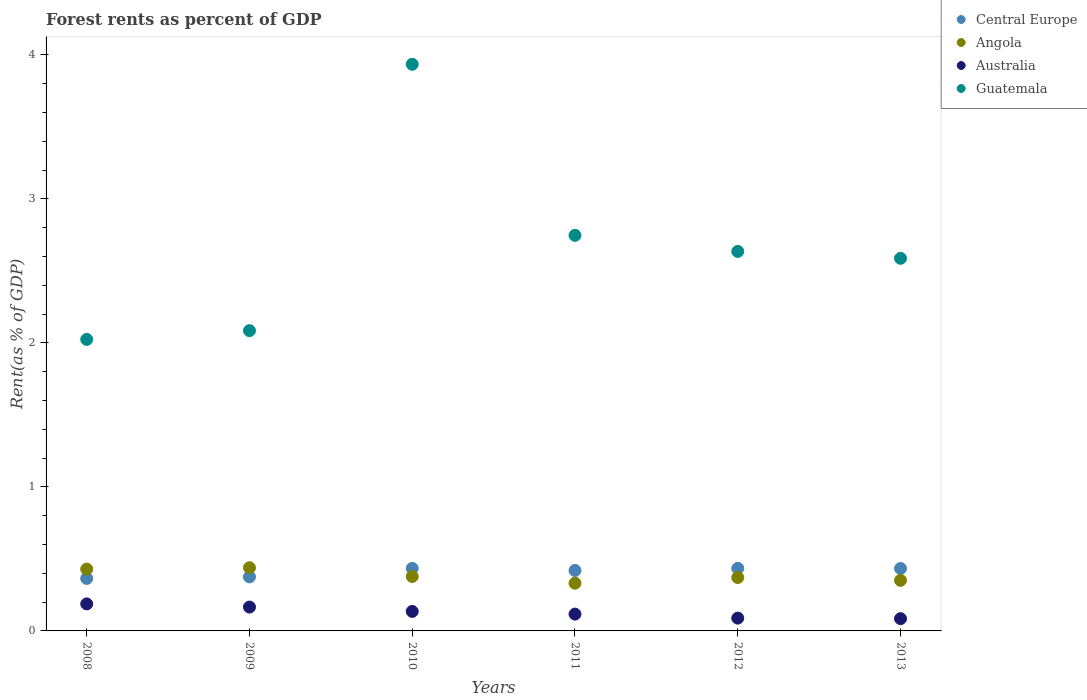What is the forest rent in Central Europe in 2013?
Offer a very short reply. 0.43. Across all years, what is the maximum forest rent in Central Europe?
Offer a very short reply. 0.43. Across all years, what is the minimum forest rent in Angola?
Give a very brief answer. 0.33. In which year was the forest rent in Central Europe minimum?
Your answer should be compact. 2008. What is the total forest rent in Angola in the graph?
Your response must be concise. 2.3. What is the difference between the forest rent in Angola in 2009 and that in 2011?
Provide a short and direct response. 0.11. What is the difference between the forest rent in Guatemala in 2011 and the forest rent in Angola in 2009?
Provide a succinct answer. 2.31. What is the average forest rent in Australia per year?
Give a very brief answer. 0.13. In the year 2010, what is the difference between the forest rent in Guatemala and forest rent in Central Europe?
Your answer should be very brief. 3.5. In how many years, is the forest rent in Guatemala greater than 2 %?
Offer a very short reply. 6. What is the ratio of the forest rent in Angola in 2009 to that in 2013?
Your answer should be very brief. 1.25. What is the difference between the highest and the second highest forest rent in Guatemala?
Offer a very short reply. 1.19. What is the difference between the highest and the lowest forest rent in Central Europe?
Offer a terse response. 0.07. In how many years, is the forest rent in Central Europe greater than the average forest rent in Central Europe taken over all years?
Ensure brevity in your answer.  4. Is it the case that in every year, the sum of the forest rent in Angola and forest rent in Central Europe  is greater than the sum of forest rent in Australia and forest rent in Guatemala?
Offer a very short reply. No. Does the forest rent in Australia monotonically increase over the years?
Make the answer very short. No. Is the forest rent in Angola strictly greater than the forest rent in Central Europe over the years?
Give a very brief answer. No. Is the forest rent in Australia strictly less than the forest rent in Central Europe over the years?
Your response must be concise. Yes. How many dotlines are there?
Make the answer very short. 4. How many years are there in the graph?
Give a very brief answer. 6. What is the difference between two consecutive major ticks on the Y-axis?
Ensure brevity in your answer.  1. Are the values on the major ticks of Y-axis written in scientific E-notation?
Offer a terse response. No. Does the graph contain any zero values?
Ensure brevity in your answer.  No. Does the graph contain grids?
Keep it short and to the point. No. What is the title of the graph?
Your answer should be very brief. Forest rents as percent of GDP. What is the label or title of the X-axis?
Keep it short and to the point. Years. What is the label or title of the Y-axis?
Make the answer very short. Rent(as % of GDP). What is the Rent(as % of GDP) of Central Europe in 2008?
Provide a short and direct response. 0.36. What is the Rent(as % of GDP) in Angola in 2008?
Keep it short and to the point. 0.43. What is the Rent(as % of GDP) in Australia in 2008?
Provide a short and direct response. 0.19. What is the Rent(as % of GDP) of Guatemala in 2008?
Make the answer very short. 2.02. What is the Rent(as % of GDP) in Central Europe in 2009?
Provide a short and direct response. 0.38. What is the Rent(as % of GDP) of Angola in 2009?
Your answer should be compact. 0.44. What is the Rent(as % of GDP) of Australia in 2009?
Your answer should be very brief. 0.17. What is the Rent(as % of GDP) of Guatemala in 2009?
Ensure brevity in your answer.  2.09. What is the Rent(as % of GDP) in Central Europe in 2010?
Make the answer very short. 0.43. What is the Rent(as % of GDP) of Angola in 2010?
Provide a short and direct response. 0.38. What is the Rent(as % of GDP) of Australia in 2010?
Keep it short and to the point. 0.14. What is the Rent(as % of GDP) in Guatemala in 2010?
Your answer should be very brief. 3.94. What is the Rent(as % of GDP) in Central Europe in 2011?
Your response must be concise. 0.42. What is the Rent(as % of GDP) of Angola in 2011?
Make the answer very short. 0.33. What is the Rent(as % of GDP) of Australia in 2011?
Give a very brief answer. 0.12. What is the Rent(as % of GDP) of Guatemala in 2011?
Your answer should be compact. 2.75. What is the Rent(as % of GDP) in Central Europe in 2012?
Your answer should be very brief. 0.43. What is the Rent(as % of GDP) of Angola in 2012?
Your answer should be very brief. 0.37. What is the Rent(as % of GDP) in Australia in 2012?
Offer a terse response. 0.09. What is the Rent(as % of GDP) of Guatemala in 2012?
Offer a terse response. 2.64. What is the Rent(as % of GDP) of Central Europe in 2013?
Your answer should be compact. 0.43. What is the Rent(as % of GDP) of Angola in 2013?
Provide a short and direct response. 0.35. What is the Rent(as % of GDP) of Australia in 2013?
Offer a very short reply. 0.09. What is the Rent(as % of GDP) of Guatemala in 2013?
Keep it short and to the point. 2.59. Across all years, what is the maximum Rent(as % of GDP) of Central Europe?
Provide a succinct answer. 0.43. Across all years, what is the maximum Rent(as % of GDP) in Angola?
Provide a short and direct response. 0.44. Across all years, what is the maximum Rent(as % of GDP) of Australia?
Your answer should be compact. 0.19. Across all years, what is the maximum Rent(as % of GDP) of Guatemala?
Offer a very short reply. 3.94. Across all years, what is the minimum Rent(as % of GDP) of Central Europe?
Keep it short and to the point. 0.36. Across all years, what is the minimum Rent(as % of GDP) in Angola?
Make the answer very short. 0.33. Across all years, what is the minimum Rent(as % of GDP) in Australia?
Provide a succinct answer. 0.09. Across all years, what is the minimum Rent(as % of GDP) in Guatemala?
Ensure brevity in your answer.  2.02. What is the total Rent(as % of GDP) of Central Europe in the graph?
Ensure brevity in your answer.  2.46. What is the total Rent(as % of GDP) of Angola in the graph?
Your answer should be compact. 2.3. What is the total Rent(as % of GDP) of Australia in the graph?
Your answer should be very brief. 0.78. What is the total Rent(as % of GDP) of Guatemala in the graph?
Provide a short and direct response. 16.02. What is the difference between the Rent(as % of GDP) in Central Europe in 2008 and that in 2009?
Provide a short and direct response. -0.01. What is the difference between the Rent(as % of GDP) of Angola in 2008 and that in 2009?
Make the answer very short. -0.01. What is the difference between the Rent(as % of GDP) of Australia in 2008 and that in 2009?
Your answer should be very brief. 0.02. What is the difference between the Rent(as % of GDP) of Guatemala in 2008 and that in 2009?
Your answer should be very brief. -0.06. What is the difference between the Rent(as % of GDP) of Central Europe in 2008 and that in 2010?
Give a very brief answer. -0.07. What is the difference between the Rent(as % of GDP) of Angola in 2008 and that in 2010?
Your answer should be very brief. 0.05. What is the difference between the Rent(as % of GDP) of Australia in 2008 and that in 2010?
Your answer should be very brief. 0.05. What is the difference between the Rent(as % of GDP) of Guatemala in 2008 and that in 2010?
Your answer should be compact. -1.91. What is the difference between the Rent(as % of GDP) of Central Europe in 2008 and that in 2011?
Keep it short and to the point. -0.06. What is the difference between the Rent(as % of GDP) in Angola in 2008 and that in 2011?
Ensure brevity in your answer.  0.1. What is the difference between the Rent(as % of GDP) of Australia in 2008 and that in 2011?
Give a very brief answer. 0.07. What is the difference between the Rent(as % of GDP) of Guatemala in 2008 and that in 2011?
Keep it short and to the point. -0.72. What is the difference between the Rent(as % of GDP) in Central Europe in 2008 and that in 2012?
Your answer should be compact. -0.07. What is the difference between the Rent(as % of GDP) of Angola in 2008 and that in 2012?
Your response must be concise. 0.06. What is the difference between the Rent(as % of GDP) in Australia in 2008 and that in 2012?
Provide a succinct answer. 0.1. What is the difference between the Rent(as % of GDP) of Guatemala in 2008 and that in 2012?
Make the answer very short. -0.61. What is the difference between the Rent(as % of GDP) in Central Europe in 2008 and that in 2013?
Provide a short and direct response. -0.07. What is the difference between the Rent(as % of GDP) in Angola in 2008 and that in 2013?
Your answer should be compact. 0.08. What is the difference between the Rent(as % of GDP) in Australia in 2008 and that in 2013?
Provide a short and direct response. 0.1. What is the difference between the Rent(as % of GDP) of Guatemala in 2008 and that in 2013?
Give a very brief answer. -0.56. What is the difference between the Rent(as % of GDP) of Central Europe in 2009 and that in 2010?
Provide a short and direct response. -0.06. What is the difference between the Rent(as % of GDP) in Angola in 2009 and that in 2010?
Keep it short and to the point. 0.06. What is the difference between the Rent(as % of GDP) in Australia in 2009 and that in 2010?
Provide a succinct answer. 0.03. What is the difference between the Rent(as % of GDP) in Guatemala in 2009 and that in 2010?
Your answer should be compact. -1.85. What is the difference between the Rent(as % of GDP) of Central Europe in 2009 and that in 2011?
Make the answer very short. -0.04. What is the difference between the Rent(as % of GDP) of Angola in 2009 and that in 2011?
Your answer should be compact. 0.11. What is the difference between the Rent(as % of GDP) in Australia in 2009 and that in 2011?
Make the answer very short. 0.05. What is the difference between the Rent(as % of GDP) of Guatemala in 2009 and that in 2011?
Provide a succinct answer. -0.66. What is the difference between the Rent(as % of GDP) of Central Europe in 2009 and that in 2012?
Provide a short and direct response. -0.06. What is the difference between the Rent(as % of GDP) of Angola in 2009 and that in 2012?
Your answer should be compact. 0.07. What is the difference between the Rent(as % of GDP) in Australia in 2009 and that in 2012?
Offer a terse response. 0.08. What is the difference between the Rent(as % of GDP) in Guatemala in 2009 and that in 2012?
Keep it short and to the point. -0.55. What is the difference between the Rent(as % of GDP) in Central Europe in 2009 and that in 2013?
Your response must be concise. -0.06. What is the difference between the Rent(as % of GDP) of Angola in 2009 and that in 2013?
Provide a succinct answer. 0.09. What is the difference between the Rent(as % of GDP) of Australia in 2009 and that in 2013?
Your answer should be very brief. 0.08. What is the difference between the Rent(as % of GDP) in Guatemala in 2009 and that in 2013?
Make the answer very short. -0.5. What is the difference between the Rent(as % of GDP) of Central Europe in 2010 and that in 2011?
Give a very brief answer. 0.01. What is the difference between the Rent(as % of GDP) of Angola in 2010 and that in 2011?
Offer a terse response. 0.05. What is the difference between the Rent(as % of GDP) in Australia in 2010 and that in 2011?
Your answer should be very brief. 0.02. What is the difference between the Rent(as % of GDP) of Guatemala in 2010 and that in 2011?
Give a very brief answer. 1.19. What is the difference between the Rent(as % of GDP) of Central Europe in 2010 and that in 2012?
Keep it short and to the point. 0. What is the difference between the Rent(as % of GDP) in Angola in 2010 and that in 2012?
Keep it short and to the point. 0.01. What is the difference between the Rent(as % of GDP) in Australia in 2010 and that in 2012?
Provide a succinct answer. 0.05. What is the difference between the Rent(as % of GDP) of Guatemala in 2010 and that in 2012?
Your response must be concise. 1.3. What is the difference between the Rent(as % of GDP) of Central Europe in 2010 and that in 2013?
Give a very brief answer. 0. What is the difference between the Rent(as % of GDP) of Angola in 2010 and that in 2013?
Make the answer very short. 0.03. What is the difference between the Rent(as % of GDP) of Australia in 2010 and that in 2013?
Provide a succinct answer. 0.05. What is the difference between the Rent(as % of GDP) in Guatemala in 2010 and that in 2013?
Your response must be concise. 1.35. What is the difference between the Rent(as % of GDP) of Central Europe in 2011 and that in 2012?
Your response must be concise. -0.01. What is the difference between the Rent(as % of GDP) of Angola in 2011 and that in 2012?
Make the answer very short. -0.04. What is the difference between the Rent(as % of GDP) in Australia in 2011 and that in 2012?
Keep it short and to the point. 0.03. What is the difference between the Rent(as % of GDP) of Guatemala in 2011 and that in 2012?
Your answer should be very brief. 0.11. What is the difference between the Rent(as % of GDP) in Central Europe in 2011 and that in 2013?
Make the answer very short. -0.01. What is the difference between the Rent(as % of GDP) in Angola in 2011 and that in 2013?
Your answer should be very brief. -0.02. What is the difference between the Rent(as % of GDP) in Australia in 2011 and that in 2013?
Offer a terse response. 0.03. What is the difference between the Rent(as % of GDP) in Guatemala in 2011 and that in 2013?
Offer a terse response. 0.16. What is the difference between the Rent(as % of GDP) in Central Europe in 2012 and that in 2013?
Your answer should be very brief. 0. What is the difference between the Rent(as % of GDP) in Angola in 2012 and that in 2013?
Your answer should be very brief. 0.02. What is the difference between the Rent(as % of GDP) of Australia in 2012 and that in 2013?
Offer a terse response. 0. What is the difference between the Rent(as % of GDP) of Guatemala in 2012 and that in 2013?
Make the answer very short. 0.05. What is the difference between the Rent(as % of GDP) in Central Europe in 2008 and the Rent(as % of GDP) in Angola in 2009?
Ensure brevity in your answer.  -0.07. What is the difference between the Rent(as % of GDP) of Central Europe in 2008 and the Rent(as % of GDP) of Australia in 2009?
Your answer should be very brief. 0.2. What is the difference between the Rent(as % of GDP) in Central Europe in 2008 and the Rent(as % of GDP) in Guatemala in 2009?
Ensure brevity in your answer.  -1.72. What is the difference between the Rent(as % of GDP) of Angola in 2008 and the Rent(as % of GDP) of Australia in 2009?
Ensure brevity in your answer.  0.26. What is the difference between the Rent(as % of GDP) of Angola in 2008 and the Rent(as % of GDP) of Guatemala in 2009?
Offer a terse response. -1.66. What is the difference between the Rent(as % of GDP) of Australia in 2008 and the Rent(as % of GDP) of Guatemala in 2009?
Make the answer very short. -1.9. What is the difference between the Rent(as % of GDP) of Central Europe in 2008 and the Rent(as % of GDP) of Angola in 2010?
Make the answer very short. -0.01. What is the difference between the Rent(as % of GDP) of Central Europe in 2008 and the Rent(as % of GDP) of Australia in 2010?
Ensure brevity in your answer.  0.23. What is the difference between the Rent(as % of GDP) in Central Europe in 2008 and the Rent(as % of GDP) in Guatemala in 2010?
Offer a very short reply. -3.57. What is the difference between the Rent(as % of GDP) of Angola in 2008 and the Rent(as % of GDP) of Australia in 2010?
Offer a very short reply. 0.29. What is the difference between the Rent(as % of GDP) in Angola in 2008 and the Rent(as % of GDP) in Guatemala in 2010?
Provide a succinct answer. -3.51. What is the difference between the Rent(as % of GDP) of Australia in 2008 and the Rent(as % of GDP) of Guatemala in 2010?
Your response must be concise. -3.75. What is the difference between the Rent(as % of GDP) of Central Europe in 2008 and the Rent(as % of GDP) of Angola in 2011?
Offer a very short reply. 0.03. What is the difference between the Rent(as % of GDP) in Central Europe in 2008 and the Rent(as % of GDP) in Australia in 2011?
Provide a succinct answer. 0.25. What is the difference between the Rent(as % of GDP) in Central Europe in 2008 and the Rent(as % of GDP) in Guatemala in 2011?
Offer a very short reply. -2.38. What is the difference between the Rent(as % of GDP) of Angola in 2008 and the Rent(as % of GDP) of Australia in 2011?
Ensure brevity in your answer.  0.31. What is the difference between the Rent(as % of GDP) in Angola in 2008 and the Rent(as % of GDP) in Guatemala in 2011?
Your response must be concise. -2.32. What is the difference between the Rent(as % of GDP) in Australia in 2008 and the Rent(as % of GDP) in Guatemala in 2011?
Offer a very short reply. -2.56. What is the difference between the Rent(as % of GDP) of Central Europe in 2008 and the Rent(as % of GDP) of Angola in 2012?
Provide a succinct answer. -0.01. What is the difference between the Rent(as % of GDP) of Central Europe in 2008 and the Rent(as % of GDP) of Australia in 2012?
Make the answer very short. 0.28. What is the difference between the Rent(as % of GDP) of Central Europe in 2008 and the Rent(as % of GDP) of Guatemala in 2012?
Offer a very short reply. -2.27. What is the difference between the Rent(as % of GDP) in Angola in 2008 and the Rent(as % of GDP) in Australia in 2012?
Your answer should be compact. 0.34. What is the difference between the Rent(as % of GDP) of Angola in 2008 and the Rent(as % of GDP) of Guatemala in 2012?
Provide a succinct answer. -2.21. What is the difference between the Rent(as % of GDP) in Australia in 2008 and the Rent(as % of GDP) in Guatemala in 2012?
Provide a succinct answer. -2.45. What is the difference between the Rent(as % of GDP) of Central Europe in 2008 and the Rent(as % of GDP) of Angola in 2013?
Your answer should be compact. 0.01. What is the difference between the Rent(as % of GDP) in Central Europe in 2008 and the Rent(as % of GDP) in Australia in 2013?
Provide a short and direct response. 0.28. What is the difference between the Rent(as % of GDP) in Central Europe in 2008 and the Rent(as % of GDP) in Guatemala in 2013?
Your answer should be very brief. -2.22. What is the difference between the Rent(as % of GDP) in Angola in 2008 and the Rent(as % of GDP) in Australia in 2013?
Your response must be concise. 0.34. What is the difference between the Rent(as % of GDP) of Angola in 2008 and the Rent(as % of GDP) of Guatemala in 2013?
Provide a short and direct response. -2.16. What is the difference between the Rent(as % of GDP) of Australia in 2008 and the Rent(as % of GDP) of Guatemala in 2013?
Give a very brief answer. -2.4. What is the difference between the Rent(as % of GDP) of Central Europe in 2009 and the Rent(as % of GDP) of Angola in 2010?
Offer a terse response. -0. What is the difference between the Rent(as % of GDP) of Central Europe in 2009 and the Rent(as % of GDP) of Australia in 2010?
Offer a very short reply. 0.24. What is the difference between the Rent(as % of GDP) in Central Europe in 2009 and the Rent(as % of GDP) in Guatemala in 2010?
Provide a succinct answer. -3.56. What is the difference between the Rent(as % of GDP) of Angola in 2009 and the Rent(as % of GDP) of Australia in 2010?
Ensure brevity in your answer.  0.3. What is the difference between the Rent(as % of GDP) in Angola in 2009 and the Rent(as % of GDP) in Guatemala in 2010?
Offer a terse response. -3.5. What is the difference between the Rent(as % of GDP) of Australia in 2009 and the Rent(as % of GDP) of Guatemala in 2010?
Give a very brief answer. -3.77. What is the difference between the Rent(as % of GDP) in Central Europe in 2009 and the Rent(as % of GDP) in Angola in 2011?
Your response must be concise. 0.04. What is the difference between the Rent(as % of GDP) in Central Europe in 2009 and the Rent(as % of GDP) in Australia in 2011?
Give a very brief answer. 0.26. What is the difference between the Rent(as % of GDP) in Central Europe in 2009 and the Rent(as % of GDP) in Guatemala in 2011?
Your response must be concise. -2.37. What is the difference between the Rent(as % of GDP) in Angola in 2009 and the Rent(as % of GDP) in Australia in 2011?
Ensure brevity in your answer.  0.32. What is the difference between the Rent(as % of GDP) in Angola in 2009 and the Rent(as % of GDP) in Guatemala in 2011?
Provide a short and direct response. -2.31. What is the difference between the Rent(as % of GDP) of Australia in 2009 and the Rent(as % of GDP) of Guatemala in 2011?
Your response must be concise. -2.58. What is the difference between the Rent(as % of GDP) in Central Europe in 2009 and the Rent(as % of GDP) in Angola in 2012?
Give a very brief answer. 0. What is the difference between the Rent(as % of GDP) in Central Europe in 2009 and the Rent(as % of GDP) in Australia in 2012?
Offer a very short reply. 0.29. What is the difference between the Rent(as % of GDP) of Central Europe in 2009 and the Rent(as % of GDP) of Guatemala in 2012?
Offer a very short reply. -2.26. What is the difference between the Rent(as % of GDP) of Angola in 2009 and the Rent(as % of GDP) of Australia in 2012?
Offer a terse response. 0.35. What is the difference between the Rent(as % of GDP) in Angola in 2009 and the Rent(as % of GDP) in Guatemala in 2012?
Your response must be concise. -2.2. What is the difference between the Rent(as % of GDP) in Australia in 2009 and the Rent(as % of GDP) in Guatemala in 2012?
Make the answer very short. -2.47. What is the difference between the Rent(as % of GDP) in Central Europe in 2009 and the Rent(as % of GDP) in Angola in 2013?
Provide a succinct answer. 0.02. What is the difference between the Rent(as % of GDP) of Central Europe in 2009 and the Rent(as % of GDP) of Australia in 2013?
Your answer should be very brief. 0.29. What is the difference between the Rent(as % of GDP) of Central Europe in 2009 and the Rent(as % of GDP) of Guatemala in 2013?
Ensure brevity in your answer.  -2.21. What is the difference between the Rent(as % of GDP) of Angola in 2009 and the Rent(as % of GDP) of Australia in 2013?
Offer a terse response. 0.35. What is the difference between the Rent(as % of GDP) of Angola in 2009 and the Rent(as % of GDP) of Guatemala in 2013?
Give a very brief answer. -2.15. What is the difference between the Rent(as % of GDP) in Australia in 2009 and the Rent(as % of GDP) in Guatemala in 2013?
Keep it short and to the point. -2.42. What is the difference between the Rent(as % of GDP) of Central Europe in 2010 and the Rent(as % of GDP) of Angola in 2011?
Keep it short and to the point. 0.1. What is the difference between the Rent(as % of GDP) in Central Europe in 2010 and the Rent(as % of GDP) in Australia in 2011?
Make the answer very short. 0.32. What is the difference between the Rent(as % of GDP) of Central Europe in 2010 and the Rent(as % of GDP) of Guatemala in 2011?
Offer a terse response. -2.31. What is the difference between the Rent(as % of GDP) of Angola in 2010 and the Rent(as % of GDP) of Australia in 2011?
Make the answer very short. 0.26. What is the difference between the Rent(as % of GDP) of Angola in 2010 and the Rent(as % of GDP) of Guatemala in 2011?
Make the answer very short. -2.37. What is the difference between the Rent(as % of GDP) in Australia in 2010 and the Rent(as % of GDP) in Guatemala in 2011?
Your answer should be compact. -2.61. What is the difference between the Rent(as % of GDP) in Central Europe in 2010 and the Rent(as % of GDP) in Angola in 2012?
Keep it short and to the point. 0.06. What is the difference between the Rent(as % of GDP) in Central Europe in 2010 and the Rent(as % of GDP) in Australia in 2012?
Offer a terse response. 0.35. What is the difference between the Rent(as % of GDP) of Central Europe in 2010 and the Rent(as % of GDP) of Guatemala in 2012?
Make the answer very short. -2.2. What is the difference between the Rent(as % of GDP) in Angola in 2010 and the Rent(as % of GDP) in Australia in 2012?
Ensure brevity in your answer.  0.29. What is the difference between the Rent(as % of GDP) in Angola in 2010 and the Rent(as % of GDP) in Guatemala in 2012?
Provide a succinct answer. -2.26. What is the difference between the Rent(as % of GDP) of Australia in 2010 and the Rent(as % of GDP) of Guatemala in 2012?
Your answer should be compact. -2.5. What is the difference between the Rent(as % of GDP) in Central Europe in 2010 and the Rent(as % of GDP) in Angola in 2013?
Your response must be concise. 0.08. What is the difference between the Rent(as % of GDP) in Central Europe in 2010 and the Rent(as % of GDP) in Australia in 2013?
Provide a short and direct response. 0.35. What is the difference between the Rent(as % of GDP) in Central Europe in 2010 and the Rent(as % of GDP) in Guatemala in 2013?
Offer a very short reply. -2.15. What is the difference between the Rent(as % of GDP) in Angola in 2010 and the Rent(as % of GDP) in Australia in 2013?
Your answer should be very brief. 0.29. What is the difference between the Rent(as % of GDP) of Angola in 2010 and the Rent(as % of GDP) of Guatemala in 2013?
Keep it short and to the point. -2.21. What is the difference between the Rent(as % of GDP) of Australia in 2010 and the Rent(as % of GDP) of Guatemala in 2013?
Keep it short and to the point. -2.45. What is the difference between the Rent(as % of GDP) of Central Europe in 2011 and the Rent(as % of GDP) of Angola in 2012?
Make the answer very short. 0.05. What is the difference between the Rent(as % of GDP) of Central Europe in 2011 and the Rent(as % of GDP) of Australia in 2012?
Your response must be concise. 0.33. What is the difference between the Rent(as % of GDP) of Central Europe in 2011 and the Rent(as % of GDP) of Guatemala in 2012?
Your response must be concise. -2.22. What is the difference between the Rent(as % of GDP) of Angola in 2011 and the Rent(as % of GDP) of Australia in 2012?
Your answer should be compact. 0.24. What is the difference between the Rent(as % of GDP) of Angola in 2011 and the Rent(as % of GDP) of Guatemala in 2012?
Make the answer very short. -2.3. What is the difference between the Rent(as % of GDP) in Australia in 2011 and the Rent(as % of GDP) in Guatemala in 2012?
Make the answer very short. -2.52. What is the difference between the Rent(as % of GDP) of Central Europe in 2011 and the Rent(as % of GDP) of Angola in 2013?
Your answer should be compact. 0.07. What is the difference between the Rent(as % of GDP) of Central Europe in 2011 and the Rent(as % of GDP) of Australia in 2013?
Your answer should be compact. 0.33. What is the difference between the Rent(as % of GDP) in Central Europe in 2011 and the Rent(as % of GDP) in Guatemala in 2013?
Your answer should be compact. -2.17. What is the difference between the Rent(as % of GDP) in Angola in 2011 and the Rent(as % of GDP) in Australia in 2013?
Offer a very short reply. 0.25. What is the difference between the Rent(as % of GDP) of Angola in 2011 and the Rent(as % of GDP) of Guatemala in 2013?
Provide a short and direct response. -2.26. What is the difference between the Rent(as % of GDP) of Australia in 2011 and the Rent(as % of GDP) of Guatemala in 2013?
Provide a short and direct response. -2.47. What is the difference between the Rent(as % of GDP) of Central Europe in 2012 and the Rent(as % of GDP) of Angola in 2013?
Offer a terse response. 0.08. What is the difference between the Rent(as % of GDP) in Central Europe in 2012 and the Rent(as % of GDP) in Australia in 2013?
Offer a very short reply. 0.35. What is the difference between the Rent(as % of GDP) in Central Europe in 2012 and the Rent(as % of GDP) in Guatemala in 2013?
Ensure brevity in your answer.  -2.15. What is the difference between the Rent(as % of GDP) in Angola in 2012 and the Rent(as % of GDP) in Australia in 2013?
Give a very brief answer. 0.29. What is the difference between the Rent(as % of GDP) of Angola in 2012 and the Rent(as % of GDP) of Guatemala in 2013?
Ensure brevity in your answer.  -2.22. What is the difference between the Rent(as % of GDP) in Australia in 2012 and the Rent(as % of GDP) in Guatemala in 2013?
Keep it short and to the point. -2.5. What is the average Rent(as % of GDP) of Central Europe per year?
Offer a very short reply. 0.41. What is the average Rent(as % of GDP) in Angola per year?
Your response must be concise. 0.38. What is the average Rent(as % of GDP) in Australia per year?
Provide a short and direct response. 0.13. What is the average Rent(as % of GDP) in Guatemala per year?
Your answer should be compact. 2.67. In the year 2008, what is the difference between the Rent(as % of GDP) in Central Europe and Rent(as % of GDP) in Angola?
Your response must be concise. -0.06. In the year 2008, what is the difference between the Rent(as % of GDP) of Central Europe and Rent(as % of GDP) of Australia?
Make the answer very short. 0.18. In the year 2008, what is the difference between the Rent(as % of GDP) of Central Europe and Rent(as % of GDP) of Guatemala?
Your answer should be very brief. -1.66. In the year 2008, what is the difference between the Rent(as % of GDP) in Angola and Rent(as % of GDP) in Australia?
Offer a very short reply. 0.24. In the year 2008, what is the difference between the Rent(as % of GDP) in Angola and Rent(as % of GDP) in Guatemala?
Provide a short and direct response. -1.6. In the year 2008, what is the difference between the Rent(as % of GDP) of Australia and Rent(as % of GDP) of Guatemala?
Your response must be concise. -1.84. In the year 2009, what is the difference between the Rent(as % of GDP) in Central Europe and Rent(as % of GDP) in Angola?
Your response must be concise. -0.06. In the year 2009, what is the difference between the Rent(as % of GDP) of Central Europe and Rent(as % of GDP) of Australia?
Provide a succinct answer. 0.21. In the year 2009, what is the difference between the Rent(as % of GDP) in Central Europe and Rent(as % of GDP) in Guatemala?
Ensure brevity in your answer.  -1.71. In the year 2009, what is the difference between the Rent(as % of GDP) of Angola and Rent(as % of GDP) of Australia?
Provide a short and direct response. 0.27. In the year 2009, what is the difference between the Rent(as % of GDP) in Angola and Rent(as % of GDP) in Guatemala?
Make the answer very short. -1.65. In the year 2009, what is the difference between the Rent(as % of GDP) in Australia and Rent(as % of GDP) in Guatemala?
Make the answer very short. -1.92. In the year 2010, what is the difference between the Rent(as % of GDP) of Central Europe and Rent(as % of GDP) of Angola?
Your answer should be compact. 0.06. In the year 2010, what is the difference between the Rent(as % of GDP) in Central Europe and Rent(as % of GDP) in Australia?
Your response must be concise. 0.3. In the year 2010, what is the difference between the Rent(as % of GDP) of Central Europe and Rent(as % of GDP) of Guatemala?
Your answer should be compact. -3.5. In the year 2010, what is the difference between the Rent(as % of GDP) in Angola and Rent(as % of GDP) in Australia?
Your answer should be very brief. 0.24. In the year 2010, what is the difference between the Rent(as % of GDP) in Angola and Rent(as % of GDP) in Guatemala?
Offer a terse response. -3.56. In the year 2010, what is the difference between the Rent(as % of GDP) in Australia and Rent(as % of GDP) in Guatemala?
Provide a succinct answer. -3.8. In the year 2011, what is the difference between the Rent(as % of GDP) of Central Europe and Rent(as % of GDP) of Angola?
Provide a succinct answer. 0.09. In the year 2011, what is the difference between the Rent(as % of GDP) in Central Europe and Rent(as % of GDP) in Australia?
Offer a very short reply. 0.3. In the year 2011, what is the difference between the Rent(as % of GDP) in Central Europe and Rent(as % of GDP) in Guatemala?
Provide a short and direct response. -2.33. In the year 2011, what is the difference between the Rent(as % of GDP) of Angola and Rent(as % of GDP) of Australia?
Make the answer very short. 0.21. In the year 2011, what is the difference between the Rent(as % of GDP) in Angola and Rent(as % of GDP) in Guatemala?
Make the answer very short. -2.42. In the year 2011, what is the difference between the Rent(as % of GDP) in Australia and Rent(as % of GDP) in Guatemala?
Give a very brief answer. -2.63. In the year 2012, what is the difference between the Rent(as % of GDP) in Central Europe and Rent(as % of GDP) in Angola?
Keep it short and to the point. 0.06. In the year 2012, what is the difference between the Rent(as % of GDP) in Central Europe and Rent(as % of GDP) in Australia?
Offer a terse response. 0.35. In the year 2012, what is the difference between the Rent(as % of GDP) in Central Europe and Rent(as % of GDP) in Guatemala?
Ensure brevity in your answer.  -2.2. In the year 2012, what is the difference between the Rent(as % of GDP) in Angola and Rent(as % of GDP) in Australia?
Your answer should be compact. 0.28. In the year 2012, what is the difference between the Rent(as % of GDP) in Angola and Rent(as % of GDP) in Guatemala?
Make the answer very short. -2.26. In the year 2012, what is the difference between the Rent(as % of GDP) in Australia and Rent(as % of GDP) in Guatemala?
Your response must be concise. -2.55. In the year 2013, what is the difference between the Rent(as % of GDP) of Central Europe and Rent(as % of GDP) of Angola?
Ensure brevity in your answer.  0.08. In the year 2013, what is the difference between the Rent(as % of GDP) in Central Europe and Rent(as % of GDP) in Australia?
Your response must be concise. 0.35. In the year 2013, what is the difference between the Rent(as % of GDP) of Central Europe and Rent(as % of GDP) of Guatemala?
Make the answer very short. -2.15. In the year 2013, what is the difference between the Rent(as % of GDP) in Angola and Rent(as % of GDP) in Australia?
Provide a succinct answer. 0.27. In the year 2013, what is the difference between the Rent(as % of GDP) of Angola and Rent(as % of GDP) of Guatemala?
Your answer should be compact. -2.24. In the year 2013, what is the difference between the Rent(as % of GDP) in Australia and Rent(as % of GDP) in Guatemala?
Your answer should be very brief. -2.5. What is the ratio of the Rent(as % of GDP) in Central Europe in 2008 to that in 2009?
Make the answer very short. 0.97. What is the ratio of the Rent(as % of GDP) of Angola in 2008 to that in 2009?
Your answer should be compact. 0.98. What is the ratio of the Rent(as % of GDP) of Australia in 2008 to that in 2009?
Offer a very short reply. 1.13. What is the ratio of the Rent(as % of GDP) in Guatemala in 2008 to that in 2009?
Provide a succinct answer. 0.97. What is the ratio of the Rent(as % of GDP) in Central Europe in 2008 to that in 2010?
Your response must be concise. 0.84. What is the ratio of the Rent(as % of GDP) in Angola in 2008 to that in 2010?
Ensure brevity in your answer.  1.14. What is the ratio of the Rent(as % of GDP) of Australia in 2008 to that in 2010?
Your answer should be compact. 1.39. What is the ratio of the Rent(as % of GDP) of Guatemala in 2008 to that in 2010?
Offer a very short reply. 0.51. What is the ratio of the Rent(as % of GDP) in Central Europe in 2008 to that in 2011?
Your response must be concise. 0.87. What is the ratio of the Rent(as % of GDP) in Angola in 2008 to that in 2011?
Provide a short and direct response. 1.3. What is the ratio of the Rent(as % of GDP) in Australia in 2008 to that in 2011?
Keep it short and to the point. 1.61. What is the ratio of the Rent(as % of GDP) in Guatemala in 2008 to that in 2011?
Provide a short and direct response. 0.74. What is the ratio of the Rent(as % of GDP) of Central Europe in 2008 to that in 2012?
Your answer should be compact. 0.84. What is the ratio of the Rent(as % of GDP) in Angola in 2008 to that in 2012?
Provide a succinct answer. 1.16. What is the ratio of the Rent(as % of GDP) of Australia in 2008 to that in 2012?
Your answer should be very brief. 2.11. What is the ratio of the Rent(as % of GDP) of Guatemala in 2008 to that in 2012?
Your answer should be compact. 0.77. What is the ratio of the Rent(as % of GDP) of Central Europe in 2008 to that in 2013?
Provide a short and direct response. 0.84. What is the ratio of the Rent(as % of GDP) in Angola in 2008 to that in 2013?
Make the answer very short. 1.22. What is the ratio of the Rent(as % of GDP) of Australia in 2008 to that in 2013?
Offer a terse response. 2.2. What is the ratio of the Rent(as % of GDP) of Guatemala in 2008 to that in 2013?
Offer a very short reply. 0.78. What is the ratio of the Rent(as % of GDP) of Central Europe in 2009 to that in 2010?
Provide a succinct answer. 0.86. What is the ratio of the Rent(as % of GDP) in Angola in 2009 to that in 2010?
Offer a terse response. 1.16. What is the ratio of the Rent(as % of GDP) in Australia in 2009 to that in 2010?
Offer a very short reply. 1.22. What is the ratio of the Rent(as % of GDP) of Guatemala in 2009 to that in 2010?
Make the answer very short. 0.53. What is the ratio of the Rent(as % of GDP) of Central Europe in 2009 to that in 2011?
Make the answer very short. 0.89. What is the ratio of the Rent(as % of GDP) of Angola in 2009 to that in 2011?
Give a very brief answer. 1.32. What is the ratio of the Rent(as % of GDP) of Australia in 2009 to that in 2011?
Make the answer very short. 1.42. What is the ratio of the Rent(as % of GDP) in Guatemala in 2009 to that in 2011?
Provide a succinct answer. 0.76. What is the ratio of the Rent(as % of GDP) in Central Europe in 2009 to that in 2012?
Ensure brevity in your answer.  0.86. What is the ratio of the Rent(as % of GDP) in Angola in 2009 to that in 2012?
Give a very brief answer. 1.18. What is the ratio of the Rent(as % of GDP) of Australia in 2009 to that in 2012?
Offer a terse response. 1.87. What is the ratio of the Rent(as % of GDP) in Guatemala in 2009 to that in 2012?
Your answer should be very brief. 0.79. What is the ratio of the Rent(as % of GDP) in Central Europe in 2009 to that in 2013?
Provide a short and direct response. 0.87. What is the ratio of the Rent(as % of GDP) of Angola in 2009 to that in 2013?
Your response must be concise. 1.25. What is the ratio of the Rent(as % of GDP) of Australia in 2009 to that in 2013?
Your response must be concise. 1.95. What is the ratio of the Rent(as % of GDP) in Guatemala in 2009 to that in 2013?
Offer a terse response. 0.81. What is the ratio of the Rent(as % of GDP) in Central Europe in 2010 to that in 2011?
Offer a terse response. 1.03. What is the ratio of the Rent(as % of GDP) of Angola in 2010 to that in 2011?
Provide a succinct answer. 1.14. What is the ratio of the Rent(as % of GDP) in Australia in 2010 to that in 2011?
Keep it short and to the point. 1.16. What is the ratio of the Rent(as % of GDP) of Guatemala in 2010 to that in 2011?
Provide a short and direct response. 1.43. What is the ratio of the Rent(as % of GDP) in Central Europe in 2010 to that in 2012?
Ensure brevity in your answer.  1. What is the ratio of the Rent(as % of GDP) in Angola in 2010 to that in 2012?
Your answer should be very brief. 1.02. What is the ratio of the Rent(as % of GDP) in Australia in 2010 to that in 2012?
Ensure brevity in your answer.  1.52. What is the ratio of the Rent(as % of GDP) in Guatemala in 2010 to that in 2012?
Provide a short and direct response. 1.49. What is the ratio of the Rent(as % of GDP) in Central Europe in 2010 to that in 2013?
Your response must be concise. 1. What is the ratio of the Rent(as % of GDP) of Angola in 2010 to that in 2013?
Give a very brief answer. 1.08. What is the ratio of the Rent(as % of GDP) in Australia in 2010 to that in 2013?
Offer a very short reply. 1.59. What is the ratio of the Rent(as % of GDP) of Guatemala in 2010 to that in 2013?
Your answer should be compact. 1.52. What is the ratio of the Rent(as % of GDP) in Central Europe in 2011 to that in 2012?
Your answer should be very brief. 0.97. What is the ratio of the Rent(as % of GDP) of Angola in 2011 to that in 2012?
Keep it short and to the point. 0.89. What is the ratio of the Rent(as % of GDP) of Australia in 2011 to that in 2012?
Your answer should be very brief. 1.31. What is the ratio of the Rent(as % of GDP) of Guatemala in 2011 to that in 2012?
Keep it short and to the point. 1.04. What is the ratio of the Rent(as % of GDP) in Central Europe in 2011 to that in 2013?
Offer a very short reply. 0.97. What is the ratio of the Rent(as % of GDP) of Angola in 2011 to that in 2013?
Your answer should be compact. 0.94. What is the ratio of the Rent(as % of GDP) in Australia in 2011 to that in 2013?
Give a very brief answer. 1.37. What is the ratio of the Rent(as % of GDP) of Guatemala in 2011 to that in 2013?
Your answer should be compact. 1.06. What is the ratio of the Rent(as % of GDP) in Central Europe in 2012 to that in 2013?
Offer a very short reply. 1. What is the ratio of the Rent(as % of GDP) of Angola in 2012 to that in 2013?
Make the answer very short. 1.06. What is the ratio of the Rent(as % of GDP) in Australia in 2012 to that in 2013?
Provide a short and direct response. 1.04. What is the ratio of the Rent(as % of GDP) of Guatemala in 2012 to that in 2013?
Your response must be concise. 1.02. What is the difference between the highest and the second highest Rent(as % of GDP) in Angola?
Give a very brief answer. 0.01. What is the difference between the highest and the second highest Rent(as % of GDP) of Australia?
Offer a terse response. 0.02. What is the difference between the highest and the second highest Rent(as % of GDP) of Guatemala?
Provide a succinct answer. 1.19. What is the difference between the highest and the lowest Rent(as % of GDP) of Central Europe?
Keep it short and to the point. 0.07. What is the difference between the highest and the lowest Rent(as % of GDP) in Angola?
Keep it short and to the point. 0.11. What is the difference between the highest and the lowest Rent(as % of GDP) of Australia?
Your response must be concise. 0.1. What is the difference between the highest and the lowest Rent(as % of GDP) in Guatemala?
Offer a terse response. 1.91. 